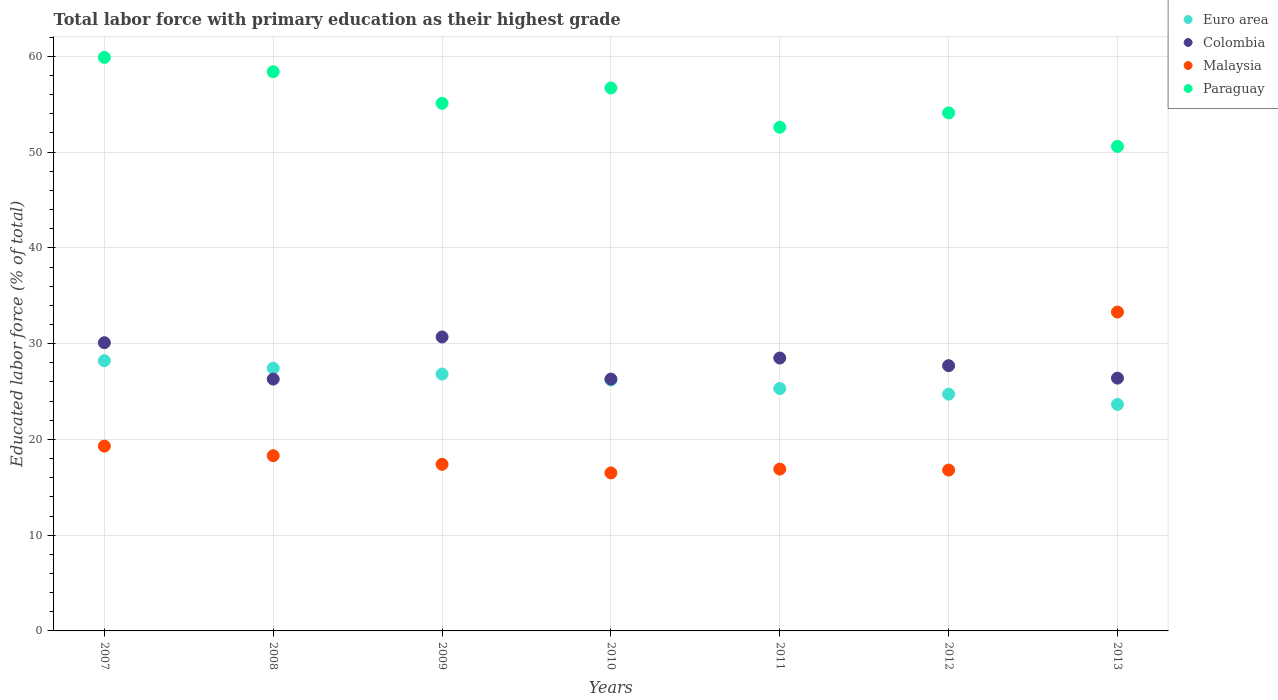How many different coloured dotlines are there?
Your answer should be very brief. 4. What is the percentage of total labor force with primary education in Paraguay in 2009?
Offer a very short reply. 55.1. Across all years, what is the maximum percentage of total labor force with primary education in Paraguay?
Your answer should be compact. 59.9. Across all years, what is the minimum percentage of total labor force with primary education in Colombia?
Make the answer very short. 26.3. In which year was the percentage of total labor force with primary education in Euro area maximum?
Give a very brief answer. 2007. In which year was the percentage of total labor force with primary education in Paraguay minimum?
Provide a succinct answer. 2013. What is the total percentage of total labor force with primary education in Malaysia in the graph?
Your answer should be compact. 138.5. What is the difference between the percentage of total labor force with primary education in Colombia in 2007 and that in 2009?
Offer a very short reply. -0.6. What is the difference between the percentage of total labor force with primary education in Colombia in 2013 and the percentage of total labor force with primary education in Euro area in 2008?
Offer a very short reply. -1.04. What is the average percentage of total labor force with primary education in Euro area per year?
Offer a terse response. 26.06. In the year 2010, what is the difference between the percentage of total labor force with primary education in Colombia and percentage of total labor force with primary education in Euro area?
Give a very brief answer. 0.09. What is the ratio of the percentage of total labor force with primary education in Paraguay in 2009 to that in 2013?
Your answer should be very brief. 1.09. What is the difference between the highest and the lowest percentage of total labor force with primary education in Euro area?
Offer a very short reply. 4.57. Is the sum of the percentage of total labor force with primary education in Malaysia in 2008 and 2012 greater than the maximum percentage of total labor force with primary education in Euro area across all years?
Provide a short and direct response. Yes. Is it the case that in every year, the sum of the percentage of total labor force with primary education in Paraguay and percentage of total labor force with primary education in Euro area  is greater than the sum of percentage of total labor force with primary education in Colombia and percentage of total labor force with primary education in Malaysia?
Offer a terse response. Yes. Is it the case that in every year, the sum of the percentage of total labor force with primary education in Euro area and percentage of total labor force with primary education in Paraguay  is greater than the percentage of total labor force with primary education in Malaysia?
Offer a terse response. Yes. Does the percentage of total labor force with primary education in Euro area monotonically increase over the years?
Provide a short and direct response. No. Is the percentage of total labor force with primary education in Colombia strictly greater than the percentage of total labor force with primary education in Paraguay over the years?
Provide a short and direct response. No. How many dotlines are there?
Your answer should be compact. 4. Are the values on the major ticks of Y-axis written in scientific E-notation?
Provide a succinct answer. No. Does the graph contain any zero values?
Provide a short and direct response. No. Where does the legend appear in the graph?
Your answer should be very brief. Top right. How many legend labels are there?
Offer a very short reply. 4. What is the title of the graph?
Provide a short and direct response. Total labor force with primary education as their highest grade. Does "Djibouti" appear as one of the legend labels in the graph?
Keep it short and to the point. No. What is the label or title of the Y-axis?
Keep it short and to the point. Educated labor force (% of total). What is the Educated labor force (% of total) of Euro area in 2007?
Offer a terse response. 28.22. What is the Educated labor force (% of total) of Colombia in 2007?
Offer a very short reply. 30.1. What is the Educated labor force (% of total) of Malaysia in 2007?
Make the answer very short. 19.3. What is the Educated labor force (% of total) in Paraguay in 2007?
Provide a short and direct response. 59.9. What is the Educated labor force (% of total) of Euro area in 2008?
Your response must be concise. 27.44. What is the Educated labor force (% of total) in Colombia in 2008?
Give a very brief answer. 26.3. What is the Educated labor force (% of total) in Malaysia in 2008?
Ensure brevity in your answer.  18.3. What is the Educated labor force (% of total) of Paraguay in 2008?
Your response must be concise. 58.4. What is the Educated labor force (% of total) in Euro area in 2009?
Provide a short and direct response. 26.83. What is the Educated labor force (% of total) of Colombia in 2009?
Provide a succinct answer. 30.7. What is the Educated labor force (% of total) in Malaysia in 2009?
Provide a succinct answer. 17.4. What is the Educated labor force (% of total) in Paraguay in 2009?
Your answer should be compact. 55.1. What is the Educated labor force (% of total) of Euro area in 2010?
Provide a succinct answer. 26.21. What is the Educated labor force (% of total) of Colombia in 2010?
Your answer should be compact. 26.3. What is the Educated labor force (% of total) of Malaysia in 2010?
Your answer should be very brief. 16.5. What is the Educated labor force (% of total) in Paraguay in 2010?
Make the answer very short. 56.7. What is the Educated labor force (% of total) of Euro area in 2011?
Offer a terse response. 25.32. What is the Educated labor force (% of total) of Colombia in 2011?
Give a very brief answer. 28.5. What is the Educated labor force (% of total) in Malaysia in 2011?
Your answer should be compact. 16.9. What is the Educated labor force (% of total) in Paraguay in 2011?
Give a very brief answer. 52.6. What is the Educated labor force (% of total) of Euro area in 2012?
Keep it short and to the point. 24.73. What is the Educated labor force (% of total) in Colombia in 2012?
Keep it short and to the point. 27.7. What is the Educated labor force (% of total) in Malaysia in 2012?
Make the answer very short. 16.8. What is the Educated labor force (% of total) of Paraguay in 2012?
Provide a succinct answer. 54.1. What is the Educated labor force (% of total) in Euro area in 2013?
Your response must be concise. 23.65. What is the Educated labor force (% of total) of Colombia in 2013?
Keep it short and to the point. 26.4. What is the Educated labor force (% of total) of Malaysia in 2013?
Your answer should be compact. 33.3. What is the Educated labor force (% of total) of Paraguay in 2013?
Offer a terse response. 50.6. Across all years, what is the maximum Educated labor force (% of total) in Euro area?
Make the answer very short. 28.22. Across all years, what is the maximum Educated labor force (% of total) in Colombia?
Your answer should be very brief. 30.7. Across all years, what is the maximum Educated labor force (% of total) of Malaysia?
Ensure brevity in your answer.  33.3. Across all years, what is the maximum Educated labor force (% of total) in Paraguay?
Keep it short and to the point. 59.9. Across all years, what is the minimum Educated labor force (% of total) of Euro area?
Offer a very short reply. 23.65. Across all years, what is the minimum Educated labor force (% of total) of Colombia?
Your response must be concise. 26.3. Across all years, what is the minimum Educated labor force (% of total) in Malaysia?
Offer a very short reply. 16.5. Across all years, what is the minimum Educated labor force (% of total) in Paraguay?
Keep it short and to the point. 50.6. What is the total Educated labor force (% of total) in Euro area in the graph?
Your answer should be compact. 182.39. What is the total Educated labor force (% of total) in Colombia in the graph?
Your response must be concise. 196. What is the total Educated labor force (% of total) of Malaysia in the graph?
Ensure brevity in your answer.  138.5. What is the total Educated labor force (% of total) of Paraguay in the graph?
Give a very brief answer. 387.4. What is the difference between the Educated labor force (% of total) in Euro area in 2007 and that in 2008?
Keep it short and to the point. 0.78. What is the difference between the Educated labor force (% of total) of Colombia in 2007 and that in 2008?
Offer a terse response. 3.8. What is the difference between the Educated labor force (% of total) of Malaysia in 2007 and that in 2008?
Make the answer very short. 1. What is the difference between the Educated labor force (% of total) in Euro area in 2007 and that in 2009?
Your response must be concise. 1.4. What is the difference between the Educated labor force (% of total) in Euro area in 2007 and that in 2010?
Provide a short and direct response. 2.01. What is the difference between the Educated labor force (% of total) of Colombia in 2007 and that in 2010?
Offer a very short reply. 3.8. What is the difference between the Educated labor force (% of total) in Malaysia in 2007 and that in 2010?
Your response must be concise. 2.8. What is the difference between the Educated labor force (% of total) in Euro area in 2007 and that in 2011?
Offer a terse response. 2.9. What is the difference between the Educated labor force (% of total) of Malaysia in 2007 and that in 2011?
Make the answer very short. 2.4. What is the difference between the Educated labor force (% of total) of Paraguay in 2007 and that in 2011?
Your answer should be very brief. 7.3. What is the difference between the Educated labor force (% of total) of Euro area in 2007 and that in 2012?
Your answer should be very brief. 3.49. What is the difference between the Educated labor force (% of total) in Malaysia in 2007 and that in 2012?
Your answer should be very brief. 2.5. What is the difference between the Educated labor force (% of total) in Paraguay in 2007 and that in 2012?
Offer a very short reply. 5.8. What is the difference between the Educated labor force (% of total) of Euro area in 2007 and that in 2013?
Give a very brief answer. 4.57. What is the difference between the Educated labor force (% of total) of Colombia in 2007 and that in 2013?
Provide a succinct answer. 3.7. What is the difference between the Educated labor force (% of total) of Euro area in 2008 and that in 2009?
Offer a very short reply. 0.61. What is the difference between the Educated labor force (% of total) in Paraguay in 2008 and that in 2009?
Your answer should be very brief. 3.3. What is the difference between the Educated labor force (% of total) in Euro area in 2008 and that in 2010?
Provide a succinct answer. 1.23. What is the difference between the Educated labor force (% of total) in Malaysia in 2008 and that in 2010?
Give a very brief answer. 1.8. What is the difference between the Educated labor force (% of total) of Paraguay in 2008 and that in 2010?
Ensure brevity in your answer.  1.7. What is the difference between the Educated labor force (% of total) in Euro area in 2008 and that in 2011?
Your answer should be compact. 2.12. What is the difference between the Educated labor force (% of total) in Colombia in 2008 and that in 2011?
Your answer should be compact. -2.2. What is the difference between the Educated labor force (% of total) in Malaysia in 2008 and that in 2011?
Ensure brevity in your answer.  1.4. What is the difference between the Educated labor force (% of total) in Euro area in 2008 and that in 2012?
Offer a very short reply. 2.71. What is the difference between the Educated labor force (% of total) in Colombia in 2008 and that in 2012?
Ensure brevity in your answer.  -1.4. What is the difference between the Educated labor force (% of total) in Paraguay in 2008 and that in 2012?
Give a very brief answer. 4.3. What is the difference between the Educated labor force (% of total) in Euro area in 2008 and that in 2013?
Your answer should be compact. 3.78. What is the difference between the Educated labor force (% of total) in Malaysia in 2008 and that in 2013?
Offer a very short reply. -15. What is the difference between the Educated labor force (% of total) in Euro area in 2009 and that in 2010?
Offer a terse response. 0.62. What is the difference between the Educated labor force (% of total) in Colombia in 2009 and that in 2010?
Your answer should be very brief. 4.4. What is the difference between the Educated labor force (% of total) in Malaysia in 2009 and that in 2010?
Offer a terse response. 0.9. What is the difference between the Educated labor force (% of total) in Paraguay in 2009 and that in 2010?
Your response must be concise. -1.6. What is the difference between the Educated labor force (% of total) in Euro area in 2009 and that in 2011?
Make the answer very short. 1.51. What is the difference between the Educated labor force (% of total) of Malaysia in 2009 and that in 2011?
Ensure brevity in your answer.  0.5. What is the difference between the Educated labor force (% of total) of Euro area in 2009 and that in 2012?
Offer a very short reply. 2.1. What is the difference between the Educated labor force (% of total) of Colombia in 2009 and that in 2012?
Make the answer very short. 3. What is the difference between the Educated labor force (% of total) in Malaysia in 2009 and that in 2012?
Keep it short and to the point. 0.6. What is the difference between the Educated labor force (% of total) in Euro area in 2009 and that in 2013?
Offer a very short reply. 3.17. What is the difference between the Educated labor force (% of total) in Malaysia in 2009 and that in 2013?
Offer a terse response. -15.9. What is the difference between the Educated labor force (% of total) in Euro area in 2010 and that in 2011?
Provide a short and direct response. 0.89. What is the difference between the Educated labor force (% of total) of Malaysia in 2010 and that in 2011?
Keep it short and to the point. -0.4. What is the difference between the Educated labor force (% of total) of Euro area in 2010 and that in 2012?
Your answer should be compact. 1.48. What is the difference between the Educated labor force (% of total) in Euro area in 2010 and that in 2013?
Ensure brevity in your answer.  2.56. What is the difference between the Educated labor force (% of total) in Malaysia in 2010 and that in 2013?
Your answer should be very brief. -16.8. What is the difference between the Educated labor force (% of total) in Euro area in 2011 and that in 2012?
Give a very brief answer. 0.59. What is the difference between the Educated labor force (% of total) in Colombia in 2011 and that in 2012?
Offer a terse response. 0.8. What is the difference between the Educated labor force (% of total) in Malaysia in 2011 and that in 2012?
Keep it short and to the point. 0.1. What is the difference between the Educated labor force (% of total) in Paraguay in 2011 and that in 2012?
Your answer should be compact. -1.5. What is the difference between the Educated labor force (% of total) of Euro area in 2011 and that in 2013?
Give a very brief answer. 1.66. What is the difference between the Educated labor force (% of total) of Colombia in 2011 and that in 2013?
Your answer should be compact. 2.1. What is the difference between the Educated labor force (% of total) in Malaysia in 2011 and that in 2013?
Your answer should be compact. -16.4. What is the difference between the Educated labor force (% of total) in Paraguay in 2011 and that in 2013?
Offer a terse response. 2. What is the difference between the Educated labor force (% of total) of Euro area in 2012 and that in 2013?
Make the answer very short. 1.07. What is the difference between the Educated labor force (% of total) of Colombia in 2012 and that in 2013?
Your answer should be very brief. 1.3. What is the difference between the Educated labor force (% of total) in Malaysia in 2012 and that in 2013?
Ensure brevity in your answer.  -16.5. What is the difference between the Educated labor force (% of total) of Euro area in 2007 and the Educated labor force (% of total) of Colombia in 2008?
Your response must be concise. 1.92. What is the difference between the Educated labor force (% of total) of Euro area in 2007 and the Educated labor force (% of total) of Malaysia in 2008?
Make the answer very short. 9.92. What is the difference between the Educated labor force (% of total) in Euro area in 2007 and the Educated labor force (% of total) in Paraguay in 2008?
Give a very brief answer. -30.18. What is the difference between the Educated labor force (% of total) in Colombia in 2007 and the Educated labor force (% of total) in Malaysia in 2008?
Ensure brevity in your answer.  11.8. What is the difference between the Educated labor force (% of total) in Colombia in 2007 and the Educated labor force (% of total) in Paraguay in 2008?
Provide a succinct answer. -28.3. What is the difference between the Educated labor force (% of total) in Malaysia in 2007 and the Educated labor force (% of total) in Paraguay in 2008?
Your answer should be very brief. -39.1. What is the difference between the Educated labor force (% of total) in Euro area in 2007 and the Educated labor force (% of total) in Colombia in 2009?
Give a very brief answer. -2.48. What is the difference between the Educated labor force (% of total) of Euro area in 2007 and the Educated labor force (% of total) of Malaysia in 2009?
Your answer should be compact. 10.82. What is the difference between the Educated labor force (% of total) of Euro area in 2007 and the Educated labor force (% of total) of Paraguay in 2009?
Make the answer very short. -26.88. What is the difference between the Educated labor force (% of total) of Malaysia in 2007 and the Educated labor force (% of total) of Paraguay in 2009?
Offer a very short reply. -35.8. What is the difference between the Educated labor force (% of total) in Euro area in 2007 and the Educated labor force (% of total) in Colombia in 2010?
Your answer should be compact. 1.92. What is the difference between the Educated labor force (% of total) of Euro area in 2007 and the Educated labor force (% of total) of Malaysia in 2010?
Provide a succinct answer. 11.72. What is the difference between the Educated labor force (% of total) of Euro area in 2007 and the Educated labor force (% of total) of Paraguay in 2010?
Keep it short and to the point. -28.48. What is the difference between the Educated labor force (% of total) in Colombia in 2007 and the Educated labor force (% of total) in Paraguay in 2010?
Ensure brevity in your answer.  -26.6. What is the difference between the Educated labor force (% of total) of Malaysia in 2007 and the Educated labor force (% of total) of Paraguay in 2010?
Your answer should be compact. -37.4. What is the difference between the Educated labor force (% of total) in Euro area in 2007 and the Educated labor force (% of total) in Colombia in 2011?
Provide a short and direct response. -0.28. What is the difference between the Educated labor force (% of total) of Euro area in 2007 and the Educated labor force (% of total) of Malaysia in 2011?
Make the answer very short. 11.32. What is the difference between the Educated labor force (% of total) in Euro area in 2007 and the Educated labor force (% of total) in Paraguay in 2011?
Offer a very short reply. -24.38. What is the difference between the Educated labor force (% of total) of Colombia in 2007 and the Educated labor force (% of total) of Paraguay in 2011?
Provide a short and direct response. -22.5. What is the difference between the Educated labor force (% of total) in Malaysia in 2007 and the Educated labor force (% of total) in Paraguay in 2011?
Provide a succinct answer. -33.3. What is the difference between the Educated labor force (% of total) of Euro area in 2007 and the Educated labor force (% of total) of Colombia in 2012?
Your answer should be compact. 0.52. What is the difference between the Educated labor force (% of total) of Euro area in 2007 and the Educated labor force (% of total) of Malaysia in 2012?
Keep it short and to the point. 11.42. What is the difference between the Educated labor force (% of total) of Euro area in 2007 and the Educated labor force (% of total) of Paraguay in 2012?
Offer a terse response. -25.88. What is the difference between the Educated labor force (% of total) in Colombia in 2007 and the Educated labor force (% of total) in Malaysia in 2012?
Offer a terse response. 13.3. What is the difference between the Educated labor force (% of total) of Colombia in 2007 and the Educated labor force (% of total) of Paraguay in 2012?
Provide a short and direct response. -24. What is the difference between the Educated labor force (% of total) in Malaysia in 2007 and the Educated labor force (% of total) in Paraguay in 2012?
Provide a short and direct response. -34.8. What is the difference between the Educated labor force (% of total) of Euro area in 2007 and the Educated labor force (% of total) of Colombia in 2013?
Keep it short and to the point. 1.82. What is the difference between the Educated labor force (% of total) of Euro area in 2007 and the Educated labor force (% of total) of Malaysia in 2013?
Your response must be concise. -5.08. What is the difference between the Educated labor force (% of total) of Euro area in 2007 and the Educated labor force (% of total) of Paraguay in 2013?
Your answer should be compact. -22.38. What is the difference between the Educated labor force (% of total) of Colombia in 2007 and the Educated labor force (% of total) of Malaysia in 2013?
Keep it short and to the point. -3.2. What is the difference between the Educated labor force (% of total) of Colombia in 2007 and the Educated labor force (% of total) of Paraguay in 2013?
Provide a short and direct response. -20.5. What is the difference between the Educated labor force (% of total) of Malaysia in 2007 and the Educated labor force (% of total) of Paraguay in 2013?
Make the answer very short. -31.3. What is the difference between the Educated labor force (% of total) in Euro area in 2008 and the Educated labor force (% of total) in Colombia in 2009?
Your answer should be compact. -3.26. What is the difference between the Educated labor force (% of total) in Euro area in 2008 and the Educated labor force (% of total) in Malaysia in 2009?
Keep it short and to the point. 10.04. What is the difference between the Educated labor force (% of total) in Euro area in 2008 and the Educated labor force (% of total) in Paraguay in 2009?
Offer a terse response. -27.66. What is the difference between the Educated labor force (% of total) in Colombia in 2008 and the Educated labor force (% of total) in Paraguay in 2009?
Your answer should be very brief. -28.8. What is the difference between the Educated labor force (% of total) of Malaysia in 2008 and the Educated labor force (% of total) of Paraguay in 2009?
Provide a short and direct response. -36.8. What is the difference between the Educated labor force (% of total) of Euro area in 2008 and the Educated labor force (% of total) of Colombia in 2010?
Provide a short and direct response. 1.14. What is the difference between the Educated labor force (% of total) in Euro area in 2008 and the Educated labor force (% of total) in Malaysia in 2010?
Offer a terse response. 10.94. What is the difference between the Educated labor force (% of total) of Euro area in 2008 and the Educated labor force (% of total) of Paraguay in 2010?
Offer a very short reply. -29.26. What is the difference between the Educated labor force (% of total) in Colombia in 2008 and the Educated labor force (% of total) in Paraguay in 2010?
Your response must be concise. -30.4. What is the difference between the Educated labor force (% of total) of Malaysia in 2008 and the Educated labor force (% of total) of Paraguay in 2010?
Your answer should be compact. -38.4. What is the difference between the Educated labor force (% of total) of Euro area in 2008 and the Educated labor force (% of total) of Colombia in 2011?
Your answer should be compact. -1.06. What is the difference between the Educated labor force (% of total) in Euro area in 2008 and the Educated labor force (% of total) in Malaysia in 2011?
Make the answer very short. 10.54. What is the difference between the Educated labor force (% of total) of Euro area in 2008 and the Educated labor force (% of total) of Paraguay in 2011?
Your response must be concise. -25.16. What is the difference between the Educated labor force (% of total) in Colombia in 2008 and the Educated labor force (% of total) in Malaysia in 2011?
Your answer should be compact. 9.4. What is the difference between the Educated labor force (% of total) in Colombia in 2008 and the Educated labor force (% of total) in Paraguay in 2011?
Provide a succinct answer. -26.3. What is the difference between the Educated labor force (% of total) in Malaysia in 2008 and the Educated labor force (% of total) in Paraguay in 2011?
Your answer should be very brief. -34.3. What is the difference between the Educated labor force (% of total) of Euro area in 2008 and the Educated labor force (% of total) of Colombia in 2012?
Keep it short and to the point. -0.26. What is the difference between the Educated labor force (% of total) in Euro area in 2008 and the Educated labor force (% of total) in Malaysia in 2012?
Your response must be concise. 10.64. What is the difference between the Educated labor force (% of total) in Euro area in 2008 and the Educated labor force (% of total) in Paraguay in 2012?
Your answer should be very brief. -26.66. What is the difference between the Educated labor force (% of total) of Colombia in 2008 and the Educated labor force (% of total) of Paraguay in 2012?
Your response must be concise. -27.8. What is the difference between the Educated labor force (% of total) of Malaysia in 2008 and the Educated labor force (% of total) of Paraguay in 2012?
Your response must be concise. -35.8. What is the difference between the Educated labor force (% of total) of Euro area in 2008 and the Educated labor force (% of total) of Colombia in 2013?
Keep it short and to the point. 1.04. What is the difference between the Educated labor force (% of total) in Euro area in 2008 and the Educated labor force (% of total) in Malaysia in 2013?
Keep it short and to the point. -5.86. What is the difference between the Educated labor force (% of total) in Euro area in 2008 and the Educated labor force (% of total) in Paraguay in 2013?
Your response must be concise. -23.16. What is the difference between the Educated labor force (% of total) of Colombia in 2008 and the Educated labor force (% of total) of Paraguay in 2013?
Provide a short and direct response. -24.3. What is the difference between the Educated labor force (% of total) in Malaysia in 2008 and the Educated labor force (% of total) in Paraguay in 2013?
Give a very brief answer. -32.3. What is the difference between the Educated labor force (% of total) in Euro area in 2009 and the Educated labor force (% of total) in Colombia in 2010?
Provide a succinct answer. 0.53. What is the difference between the Educated labor force (% of total) of Euro area in 2009 and the Educated labor force (% of total) of Malaysia in 2010?
Provide a succinct answer. 10.33. What is the difference between the Educated labor force (% of total) of Euro area in 2009 and the Educated labor force (% of total) of Paraguay in 2010?
Provide a succinct answer. -29.87. What is the difference between the Educated labor force (% of total) of Colombia in 2009 and the Educated labor force (% of total) of Paraguay in 2010?
Your answer should be compact. -26. What is the difference between the Educated labor force (% of total) of Malaysia in 2009 and the Educated labor force (% of total) of Paraguay in 2010?
Provide a short and direct response. -39.3. What is the difference between the Educated labor force (% of total) of Euro area in 2009 and the Educated labor force (% of total) of Colombia in 2011?
Ensure brevity in your answer.  -1.67. What is the difference between the Educated labor force (% of total) in Euro area in 2009 and the Educated labor force (% of total) in Malaysia in 2011?
Offer a terse response. 9.93. What is the difference between the Educated labor force (% of total) in Euro area in 2009 and the Educated labor force (% of total) in Paraguay in 2011?
Your answer should be compact. -25.77. What is the difference between the Educated labor force (% of total) in Colombia in 2009 and the Educated labor force (% of total) in Malaysia in 2011?
Make the answer very short. 13.8. What is the difference between the Educated labor force (% of total) of Colombia in 2009 and the Educated labor force (% of total) of Paraguay in 2011?
Keep it short and to the point. -21.9. What is the difference between the Educated labor force (% of total) of Malaysia in 2009 and the Educated labor force (% of total) of Paraguay in 2011?
Provide a short and direct response. -35.2. What is the difference between the Educated labor force (% of total) in Euro area in 2009 and the Educated labor force (% of total) in Colombia in 2012?
Your answer should be compact. -0.87. What is the difference between the Educated labor force (% of total) of Euro area in 2009 and the Educated labor force (% of total) of Malaysia in 2012?
Offer a very short reply. 10.03. What is the difference between the Educated labor force (% of total) of Euro area in 2009 and the Educated labor force (% of total) of Paraguay in 2012?
Ensure brevity in your answer.  -27.27. What is the difference between the Educated labor force (% of total) in Colombia in 2009 and the Educated labor force (% of total) in Paraguay in 2012?
Your answer should be compact. -23.4. What is the difference between the Educated labor force (% of total) in Malaysia in 2009 and the Educated labor force (% of total) in Paraguay in 2012?
Offer a very short reply. -36.7. What is the difference between the Educated labor force (% of total) of Euro area in 2009 and the Educated labor force (% of total) of Colombia in 2013?
Offer a terse response. 0.43. What is the difference between the Educated labor force (% of total) in Euro area in 2009 and the Educated labor force (% of total) in Malaysia in 2013?
Your answer should be compact. -6.47. What is the difference between the Educated labor force (% of total) of Euro area in 2009 and the Educated labor force (% of total) of Paraguay in 2013?
Offer a very short reply. -23.77. What is the difference between the Educated labor force (% of total) in Colombia in 2009 and the Educated labor force (% of total) in Paraguay in 2013?
Your answer should be compact. -19.9. What is the difference between the Educated labor force (% of total) in Malaysia in 2009 and the Educated labor force (% of total) in Paraguay in 2013?
Provide a short and direct response. -33.2. What is the difference between the Educated labor force (% of total) of Euro area in 2010 and the Educated labor force (% of total) of Colombia in 2011?
Your response must be concise. -2.29. What is the difference between the Educated labor force (% of total) of Euro area in 2010 and the Educated labor force (% of total) of Malaysia in 2011?
Your answer should be compact. 9.31. What is the difference between the Educated labor force (% of total) in Euro area in 2010 and the Educated labor force (% of total) in Paraguay in 2011?
Give a very brief answer. -26.39. What is the difference between the Educated labor force (% of total) of Colombia in 2010 and the Educated labor force (% of total) of Paraguay in 2011?
Your answer should be compact. -26.3. What is the difference between the Educated labor force (% of total) in Malaysia in 2010 and the Educated labor force (% of total) in Paraguay in 2011?
Ensure brevity in your answer.  -36.1. What is the difference between the Educated labor force (% of total) in Euro area in 2010 and the Educated labor force (% of total) in Colombia in 2012?
Offer a very short reply. -1.49. What is the difference between the Educated labor force (% of total) of Euro area in 2010 and the Educated labor force (% of total) of Malaysia in 2012?
Your answer should be very brief. 9.41. What is the difference between the Educated labor force (% of total) in Euro area in 2010 and the Educated labor force (% of total) in Paraguay in 2012?
Give a very brief answer. -27.89. What is the difference between the Educated labor force (% of total) of Colombia in 2010 and the Educated labor force (% of total) of Malaysia in 2012?
Your answer should be compact. 9.5. What is the difference between the Educated labor force (% of total) of Colombia in 2010 and the Educated labor force (% of total) of Paraguay in 2012?
Your answer should be compact. -27.8. What is the difference between the Educated labor force (% of total) in Malaysia in 2010 and the Educated labor force (% of total) in Paraguay in 2012?
Give a very brief answer. -37.6. What is the difference between the Educated labor force (% of total) of Euro area in 2010 and the Educated labor force (% of total) of Colombia in 2013?
Provide a succinct answer. -0.19. What is the difference between the Educated labor force (% of total) in Euro area in 2010 and the Educated labor force (% of total) in Malaysia in 2013?
Your answer should be very brief. -7.09. What is the difference between the Educated labor force (% of total) of Euro area in 2010 and the Educated labor force (% of total) of Paraguay in 2013?
Keep it short and to the point. -24.39. What is the difference between the Educated labor force (% of total) in Colombia in 2010 and the Educated labor force (% of total) in Malaysia in 2013?
Provide a short and direct response. -7. What is the difference between the Educated labor force (% of total) of Colombia in 2010 and the Educated labor force (% of total) of Paraguay in 2013?
Provide a succinct answer. -24.3. What is the difference between the Educated labor force (% of total) in Malaysia in 2010 and the Educated labor force (% of total) in Paraguay in 2013?
Offer a very short reply. -34.1. What is the difference between the Educated labor force (% of total) in Euro area in 2011 and the Educated labor force (% of total) in Colombia in 2012?
Ensure brevity in your answer.  -2.38. What is the difference between the Educated labor force (% of total) in Euro area in 2011 and the Educated labor force (% of total) in Malaysia in 2012?
Offer a terse response. 8.52. What is the difference between the Educated labor force (% of total) in Euro area in 2011 and the Educated labor force (% of total) in Paraguay in 2012?
Offer a terse response. -28.78. What is the difference between the Educated labor force (% of total) of Colombia in 2011 and the Educated labor force (% of total) of Malaysia in 2012?
Ensure brevity in your answer.  11.7. What is the difference between the Educated labor force (% of total) of Colombia in 2011 and the Educated labor force (% of total) of Paraguay in 2012?
Offer a terse response. -25.6. What is the difference between the Educated labor force (% of total) of Malaysia in 2011 and the Educated labor force (% of total) of Paraguay in 2012?
Your answer should be compact. -37.2. What is the difference between the Educated labor force (% of total) of Euro area in 2011 and the Educated labor force (% of total) of Colombia in 2013?
Provide a succinct answer. -1.08. What is the difference between the Educated labor force (% of total) in Euro area in 2011 and the Educated labor force (% of total) in Malaysia in 2013?
Offer a very short reply. -7.98. What is the difference between the Educated labor force (% of total) of Euro area in 2011 and the Educated labor force (% of total) of Paraguay in 2013?
Give a very brief answer. -25.28. What is the difference between the Educated labor force (% of total) in Colombia in 2011 and the Educated labor force (% of total) in Paraguay in 2013?
Offer a very short reply. -22.1. What is the difference between the Educated labor force (% of total) of Malaysia in 2011 and the Educated labor force (% of total) of Paraguay in 2013?
Your answer should be very brief. -33.7. What is the difference between the Educated labor force (% of total) of Euro area in 2012 and the Educated labor force (% of total) of Colombia in 2013?
Provide a succinct answer. -1.67. What is the difference between the Educated labor force (% of total) in Euro area in 2012 and the Educated labor force (% of total) in Malaysia in 2013?
Your answer should be very brief. -8.57. What is the difference between the Educated labor force (% of total) in Euro area in 2012 and the Educated labor force (% of total) in Paraguay in 2013?
Your answer should be very brief. -25.87. What is the difference between the Educated labor force (% of total) of Colombia in 2012 and the Educated labor force (% of total) of Paraguay in 2013?
Offer a very short reply. -22.9. What is the difference between the Educated labor force (% of total) in Malaysia in 2012 and the Educated labor force (% of total) in Paraguay in 2013?
Ensure brevity in your answer.  -33.8. What is the average Educated labor force (% of total) of Euro area per year?
Your response must be concise. 26.06. What is the average Educated labor force (% of total) of Malaysia per year?
Keep it short and to the point. 19.79. What is the average Educated labor force (% of total) in Paraguay per year?
Make the answer very short. 55.34. In the year 2007, what is the difference between the Educated labor force (% of total) of Euro area and Educated labor force (% of total) of Colombia?
Keep it short and to the point. -1.88. In the year 2007, what is the difference between the Educated labor force (% of total) in Euro area and Educated labor force (% of total) in Malaysia?
Your response must be concise. 8.92. In the year 2007, what is the difference between the Educated labor force (% of total) of Euro area and Educated labor force (% of total) of Paraguay?
Offer a terse response. -31.68. In the year 2007, what is the difference between the Educated labor force (% of total) of Colombia and Educated labor force (% of total) of Paraguay?
Your answer should be compact. -29.8. In the year 2007, what is the difference between the Educated labor force (% of total) in Malaysia and Educated labor force (% of total) in Paraguay?
Provide a succinct answer. -40.6. In the year 2008, what is the difference between the Educated labor force (% of total) of Euro area and Educated labor force (% of total) of Colombia?
Your answer should be very brief. 1.14. In the year 2008, what is the difference between the Educated labor force (% of total) of Euro area and Educated labor force (% of total) of Malaysia?
Keep it short and to the point. 9.14. In the year 2008, what is the difference between the Educated labor force (% of total) of Euro area and Educated labor force (% of total) of Paraguay?
Your answer should be very brief. -30.96. In the year 2008, what is the difference between the Educated labor force (% of total) of Colombia and Educated labor force (% of total) of Paraguay?
Your answer should be very brief. -32.1. In the year 2008, what is the difference between the Educated labor force (% of total) in Malaysia and Educated labor force (% of total) in Paraguay?
Provide a succinct answer. -40.1. In the year 2009, what is the difference between the Educated labor force (% of total) in Euro area and Educated labor force (% of total) in Colombia?
Give a very brief answer. -3.87. In the year 2009, what is the difference between the Educated labor force (% of total) of Euro area and Educated labor force (% of total) of Malaysia?
Make the answer very short. 9.43. In the year 2009, what is the difference between the Educated labor force (% of total) in Euro area and Educated labor force (% of total) in Paraguay?
Your answer should be very brief. -28.27. In the year 2009, what is the difference between the Educated labor force (% of total) of Colombia and Educated labor force (% of total) of Paraguay?
Provide a succinct answer. -24.4. In the year 2009, what is the difference between the Educated labor force (% of total) of Malaysia and Educated labor force (% of total) of Paraguay?
Provide a short and direct response. -37.7. In the year 2010, what is the difference between the Educated labor force (% of total) in Euro area and Educated labor force (% of total) in Colombia?
Your answer should be compact. -0.09. In the year 2010, what is the difference between the Educated labor force (% of total) of Euro area and Educated labor force (% of total) of Malaysia?
Offer a terse response. 9.71. In the year 2010, what is the difference between the Educated labor force (% of total) of Euro area and Educated labor force (% of total) of Paraguay?
Offer a terse response. -30.49. In the year 2010, what is the difference between the Educated labor force (% of total) of Colombia and Educated labor force (% of total) of Malaysia?
Your answer should be compact. 9.8. In the year 2010, what is the difference between the Educated labor force (% of total) in Colombia and Educated labor force (% of total) in Paraguay?
Offer a terse response. -30.4. In the year 2010, what is the difference between the Educated labor force (% of total) of Malaysia and Educated labor force (% of total) of Paraguay?
Provide a succinct answer. -40.2. In the year 2011, what is the difference between the Educated labor force (% of total) in Euro area and Educated labor force (% of total) in Colombia?
Your answer should be compact. -3.18. In the year 2011, what is the difference between the Educated labor force (% of total) of Euro area and Educated labor force (% of total) of Malaysia?
Ensure brevity in your answer.  8.42. In the year 2011, what is the difference between the Educated labor force (% of total) in Euro area and Educated labor force (% of total) in Paraguay?
Your answer should be very brief. -27.28. In the year 2011, what is the difference between the Educated labor force (% of total) in Colombia and Educated labor force (% of total) in Malaysia?
Give a very brief answer. 11.6. In the year 2011, what is the difference between the Educated labor force (% of total) of Colombia and Educated labor force (% of total) of Paraguay?
Ensure brevity in your answer.  -24.1. In the year 2011, what is the difference between the Educated labor force (% of total) in Malaysia and Educated labor force (% of total) in Paraguay?
Make the answer very short. -35.7. In the year 2012, what is the difference between the Educated labor force (% of total) in Euro area and Educated labor force (% of total) in Colombia?
Your response must be concise. -2.97. In the year 2012, what is the difference between the Educated labor force (% of total) in Euro area and Educated labor force (% of total) in Malaysia?
Keep it short and to the point. 7.93. In the year 2012, what is the difference between the Educated labor force (% of total) in Euro area and Educated labor force (% of total) in Paraguay?
Your answer should be very brief. -29.37. In the year 2012, what is the difference between the Educated labor force (% of total) in Colombia and Educated labor force (% of total) in Malaysia?
Your answer should be very brief. 10.9. In the year 2012, what is the difference between the Educated labor force (% of total) in Colombia and Educated labor force (% of total) in Paraguay?
Ensure brevity in your answer.  -26.4. In the year 2012, what is the difference between the Educated labor force (% of total) in Malaysia and Educated labor force (% of total) in Paraguay?
Provide a short and direct response. -37.3. In the year 2013, what is the difference between the Educated labor force (% of total) of Euro area and Educated labor force (% of total) of Colombia?
Your response must be concise. -2.75. In the year 2013, what is the difference between the Educated labor force (% of total) in Euro area and Educated labor force (% of total) in Malaysia?
Your answer should be compact. -9.65. In the year 2013, what is the difference between the Educated labor force (% of total) of Euro area and Educated labor force (% of total) of Paraguay?
Ensure brevity in your answer.  -26.95. In the year 2013, what is the difference between the Educated labor force (% of total) in Colombia and Educated labor force (% of total) in Malaysia?
Offer a terse response. -6.9. In the year 2013, what is the difference between the Educated labor force (% of total) in Colombia and Educated labor force (% of total) in Paraguay?
Keep it short and to the point. -24.2. In the year 2013, what is the difference between the Educated labor force (% of total) in Malaysia and Educated labor force (% of total) in Paraguay?
Provide a succinct answer. -17.3. What is the ratio of the Educated labor force (% of total) in Euro area in 2007 to that in 2008?
Offer a terse response. 1.03. What is the ratio of the Educated labor force (% of total) in Colombia in 2007 to that in 2008?
Offer a very short reply. 1.14. What is the ratio of the Educated labor force (% of total) of Malaysia in 2007 to that in 2008?
Your answer should be very brief. 1.05. What is the ratio of the Educated labor force (% of total) in Paraguay in 2007 to that in 2008?
Ensure brevity in your answer.  1.03. What is the ratio of the Educated labor force (% of total) of Euro area in 2007 to that in 2009?
Offer a very short reply. 1.05. What is the ratio of the Educated labor force (% of total) in Colombia in 2007 to that in 2009?
Give a very brief answer. 0.98. What is the ratio of the Educated labor force (% of total) in Malaysia in 2007 to that in 2009?
Make the answer very short. 1.11. What is the ratio of the Educated labor force (% of total) of Paraguay in 2007 to that in 2009?
Offer a very short reply. 1.09. What is the ratio of the Educated labor force (% of total) of Euro area in 2007 to that in 2010?
Make the answer very short. 1.08. What is the ratio of the Educated labor force (% of total) of Colombia in 2007 to that in 2010?
Your response must be concise. 1.14. What is the ratio of the Educated labor force (% of total) of Malaysia in 2007 to that in 2010?
Provide a succinct answer. 1.17. What is the ratio of the Educated labor force (% of total) in Paraguay in 2007 to that in 2010?
Give a very brief answer. 1.06. What is the ratio of the Educated labor force (% of total) in Euro area in 2007 to that in 2011?
Keep it short and to the point. 1.11. What is the ratio of the Educated labor force (% of total) of Colombia in 2007 to that in 2011?
Offer a very short reply. 1.06. What is the ratio of the Educated labor force (% of total) in Malaysia in 2007 to that in 2011?
Your response must be concise. 1.14. What is the ratio of the Educated labor force (% of total) in Paraguay in 2007 to that in 2011?
Keep it short and to the point. 1.14. What is the ratio of the Educated labor force (% of total) in Euro area in 2007 to that in 2012?
Give a very brief answer. 1.14. What is the ratio of the Educated labor force (% of total) of Colombia in 2007 to that in 2012?
Your answer should be very brief. 1.09. What is the ratio of the Educated labor force (% of total) in Malaysia in 2007 to that in 2012?
Give a very brief answer. 1.15. What is the ratio of the Educated labor force (% of total) of Paraguay in 2007 to that in 2012?
Your response must be concise. 1.11. What is the ratio of the Educated labor force (% of total) in Euro area in 2007 to that in 2013?
Your answer should be compact. 1.19. What is the ratio of the Educated labor force (% of total) in Colombia in 2007 to that in 2013?
Your answer should be compact. 1.14. What is the ratio of the Educated labor force (% of total) of Malaysia in 2007 to that in 2013?
Offer a very short reply. 0.58. What is the ratio of the Educated labor force (% of total) in Paraguay in 2007 to that in 2013?
Offer a terse response. 1.18. What is the ratio of the Educated labor force (% of total) of Euro area in 2008 to that in 2009?
Ensure brevity in your answer.  1.02. What is the ratio of the Educated labor force (% of total) of Colombia in 2008 to that in 2009?
Ensure brevity in your answer.  0.86. What is the ratio of the Educated labor force (% of total) of Malaysia in 2008 to that in 2009?
Give a very brief answer. 1.05. What is the ratio of the Educated labor force (% of total) in Paraguay in 2008 to that in 2009?
Make the answer very short. 1.06. What is the ratio of the Educated labor force (% of total) in Euro area in 2008 to that in 2010?
Your answer should be compact. 1.05. What is the ratio of the Educated labor force (% of total) of Malaysia in 2008 to that in 2010?
Ensure brevity in your answer.  1.11. What is the ratio of the Educated labor force (% of total) of Paraguay in 2008 to that in 2010?
Offer a very short reply. 1.03. What is the ratio of the Educated labor force (% of total) of Euro area in 2008 to that in 2011?
Make the answer very short. 1.08. What is the ratio of the Educated labor force (% of total) in Colombia in 2008 to that in 2011?
Offer a terse response. 0.92. What is the ratio of the Educated labor force (% of total) in Malaysia in 2008 to that in 2011?
Offer a terse response. 1.08. What is the ratio of the Educated labor force (% of total) in Paraguay in 2008 to that in 2011?
Your answer should be compact. 1.11. What is the ratio of the Educated labor force (% of total) of Euro area in 2008 to that in 2012?
Ensure brevity in your answer.  1.11. What is the ratio of the Educated labor force (% of total) of Colombia in 2008 to that in 2012?
Offer a terse response. 0.95. What is the ratio of the Educated labor force (% of total) in Malaysia in 2008 to that in 2012?
Give a very brief answer. 1.09. What is the ratio of the Educated labor force (% of total) in Paraguay in 2008 to that in 2012?
Give a very brief answer. 1.08. What is the ratio of the Educated labor force (% of total) in Euro area in 2008 to that in 2013?
Ensure brevity in your answer.  1.16. What is the ratio of the Educated labor force (% of total) of Colombia in 2008 to that in 2013?
Offer a terse response. 1. What is the ratio of the Educated labor force (% of total) of Malaysia in 2008 to that in 2013?
Your response must be concise. 0.55. What is the ratio of the Educated labor force (% of total) in Paraguay in 2008 to that in 2013?
Make the answer very short. 1.15. What is the ratio of the Educated labor force (% of total) in Euro area in 2009 to that in 2010?
Your response must be concise. 1.02. What is the ratio of the Educated labor force (% of total) of Colombia in 2009 to that in 2010?
Offer a very short reply. 1.17. What is the ratio of the Educated labor force (% of total) of Malaysia in 2009 to that in 2010?
Your answer should be compact. 1.05. What is the ratio of the Educated labor force (% of total) in Paraguay in 2009 to that in 2010?
Your response must be concise. 0.97. What is the ratio of the Educated labor force (% of total) in Euro area in 2009 to that in 2011?
Provide a succinct answer. 1.06. What is the ratio of the Educated labor force (% of total) in Colombia in 2009 to that in 2011?
Make the answer very short. 1.08. What is the ratio of the Educated labor force (% of total) of Malaysia in 2009 to that in 2011?
Provide a succinct answer. 1.03. What is the ratio of the Educated labor force (% of total) of Paraguay in 2009 to that in 2011?
Your response must be concise. 1.05. What is the ratio of the Educated labor force (% of total) of Euro area in 2009 to that in 2012?
Your answer should be compact. 1.08. What is the ratio of the Educated labor force (% of total) in Colombia in 2009 to that in 2012?
Give a very brief answer. 1.11. What is the ratio of the Educated labor force (% of total) of Malaysia in 2009 to that in 2012?
Keep it short and to the point. 1.04. What is the ratio of the Educated labor force (% of total) of Paraguay in 2009 to that in 2012?
Your answer should be very brief. 1.02. What is the ratio of the Educated labor force (% of total) in Euro area in 2009 to that in 2013?
Make the answer very short. 1.13. What is the ratio of the Educated labor force (% of total) in Colombia in 2009 to that in 2013?
Provide a succinct answer. 1.16. What is the ratio of the Educated labor force (% of total) in Malaysia in 2009 to that in 2013?
Provide a short and direct response. 0.52. What is the ratio of the Educated labor force (% of total) of Paraguay in 2009 to that in 2013?
Offer a terse response. 1.09. What is the ratio of the Educated labor force (% of total) of Euro area in 2010 to that in 2011?
Offer a terse response. 1.04. What is the ratio of the Educated labor force (% of total) in Colombia in 2010 to that in 2011?
Offer a very short reply. 0.92. What is the ratio of the Educated labor force (% of total) in Malaysia in 2010 to that in 2011?
Provide a succinct answer. 0.98. What is the ratio of the Educated labor force (% of total) in Paraguay in 2010 to that in 2011?
Your answer should be compact. 1.08. What is the ratio of the Educated labor force (% of total) in Euro area in 2010 to that in 2012?
Give a very brief answer. 1.06. What is the ratio of the Educated labor force (% of total) of Colombia in 2010 to that in 2012?
Provide a succinct answer. 0.95. What is the ratio of the Educated labor force (% of total) in Malaysia in 2010 to that in 2012?
Ensure brevity in your answer.  0.98. What is the ratio of the Educated labor force (% of total) of Paraguay in 2010 to that in 2012?
Your answer should be compact. 1.05. What is the ratio of the Educated labor force (% of total) in Euro area in 2010 to that in 2013?
Your answer should be compact. 1.11. What is the ratio of the Educated labor force (% of total) of Malaysia in 2010 to that in 2013?
Provide a succinct answer. 0.5. What is the ratio of the Educated labor force (% of total) in Paraguay in 2010 to that in 2013?
Provide a succinct answer. 1.12. What is the ratio of the Educated labor force (% of total) in Euro area in 2011 to that in 2012?
Provide a succinct answer. 1.02. What is the ratio of the Educated labor force (% of total) in Colombia in 2011 to that in 2012?
Offer a terse response. 1.03. What is the ratio of the Educated labor force (% of total) in Paraguay in 2011 to that in 2012?
Keep it short and to the point. 0.97. What is the ratio of the Educated labor force (% of total) of Euro area in 2011 to that in 2013?
Ensure brevity in your answer.  1.07. What is the ratio of the Educated labor force (% of total) of Colombia in 2011 to that in 2013?
Your answer should be compact. 1.08. What is the ratio of the Educated labor force (% of total) of Malaysia in 2011 to that in 2013?
Provide a succinct answer. 0.51. What is the ratio of the Educated labor force (% of total) of Paraguay in 2011 to that in 2013?
Offer a terse response. 1.04. What is the ratio of the Educated labor force (% of total) of Euro area in 2012 to that in 2013?
Give a very brief answer. 1.05. What is the ratio of the Educated labor force (% of total) of Colombia in 2012 to that in 2013?
Give a very brief answer. 1.05. What is the ratio of the Educated labor force (% of total) of Malaysia in 2012 to that in 2013?
Your answer should be compact. 0.5. What is the ratio of the Educated labor force (% of total) in Paraguay in 2012 to that in 2013?
Give a very brief answer. 1.07. What is the difference between the highest and the second highest Educated labor force (% of total) of Euro area?
Keep it short and to the point. 0.78. What is the difference between the highest and the second highest Educated labor force (% of total) of Malaysia?
Ensure brevity in your answer.  14. What is the difference between the highest and the second highest Educated labor force (% of total) of Paraguay?
Offer a very short reply. 1.5. What is the difference between the highest and the lowest Educated labor force (% of total) in Euro area?
Your response must be concise. 4.57. What is the difference between the highest and the lowest Educated labor force (% of total) of Malaysia?
Give a very brief answer. 16.8. What is the difference between the highest and the lowest Educated labor force (% of total) of Paraguay?
Your response must be concise. 9.3. 